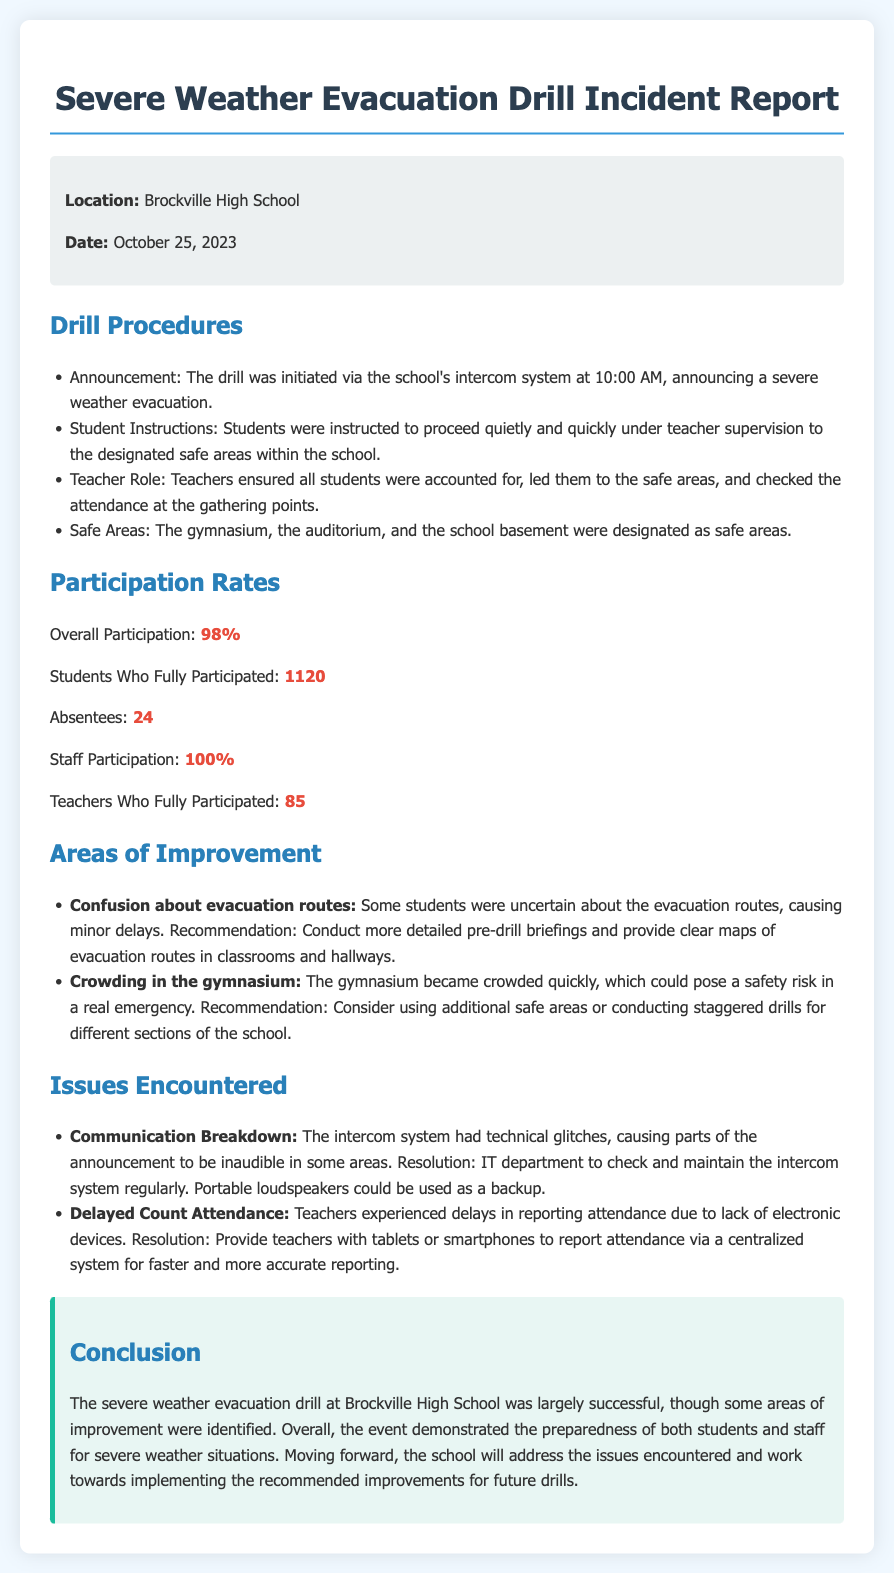What was the location of the drill? The location of the drill is explicitly mentioned in the document as Brockville High School.
Answer: Brockville High School What was the date of the drill? The document states the drill took place on October 25, 2023.
Answer: October 25, 2023 What was the overall participation rate? The document lists the overall participation rate as 98%.
Answer: 98% How many students fully participated? According to the participation section, 1120 students fully participated in the drill.
Answer: 1120 What issue was encountered regarding the intercom system? The information in the document specifies that there was a communication breakdown due to technical glitches.
Answer: Communication Breakdown What was a suggested improvement regarding evacuation routes? The document recommends conducting more detailed pre-drill briefings and providing clear maps of evacuation routes.
Answer: Detailed pre-drill briefings What was a problem faced during attendance reporting? The document mentions that teachers experienced delays in reporting attendance due to lack of electronic devices.
Answer: Delayed Count Attendance What additional safe area was used among the designated safe areas? The document lists the gymnasium, the auditorium, and the school basement as designated safe areas.
Answer: School basement What percentage of staff participated in the drill? The participation rates in the document indicate that 100% of staff participated.
Answer: 100% What was the overall conclusion regarding the drill? The conclusion section summarizes that the drill was largely successful but identified some areas for improvement.
Answer: Largely successful 